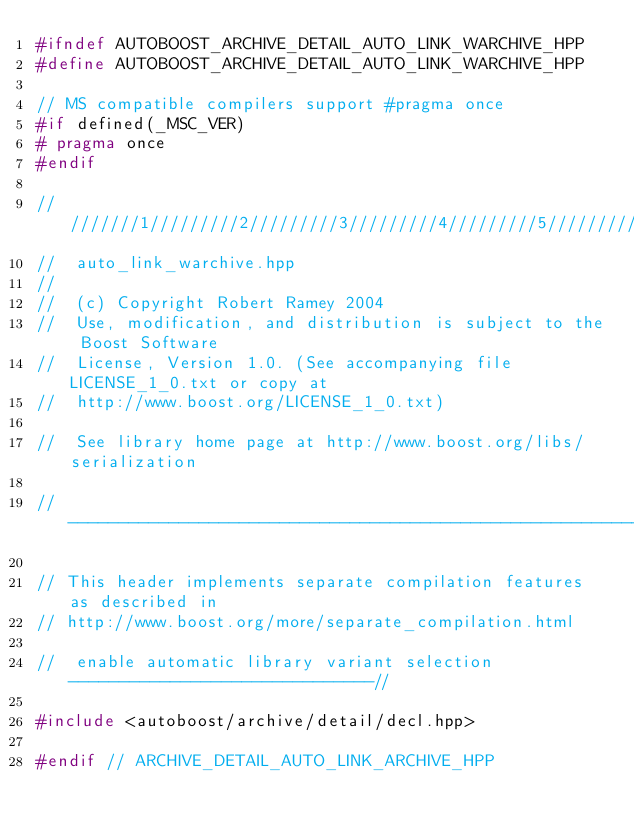<code> <loc_0><loc_0><loc_500><loc_500><_C++_>#ifndef AUTOBOOST_ARCHIVE_DETAIL_AUTO_LINK_WARCHIVE_HPP
#define AUTOBOOST_ARCHIVE_DETAIL_AUTO_LINK_WARCHIVE_HPP

// MS compatible compilers support #pragma once
#if defined(_MSC_VER)
# pragma once
#endif

/////////1/////////2/////////3/////////4/////////5/////////6/////////7/////////8
//  auto_link_warchive.hpp
//
//  (c) Copyright Robert Ramey 2004
//  Use, modification, and distribution is subject to the Boost Software
//  License, Version 1.0. (See accompanying file LICENSE_1_0.txt or copy at
//  http://www.boost.org/LICENSE_1_0.txt)

//  See library home page at http://www.boost.org/libs/serialization

//----------------------------------------------------------------------------//

// This header implements separate compilation features as described in
// http://www.boost.org/more/separate_compilation.html

//  enable automatic library variant selection  ------------------------------//

#include <autoboost/archive/detail/decl.hpp>

#endif // ARCHIVE_DETAIL_AUTO_LINK_ARCHIVE_HPP
</code> 